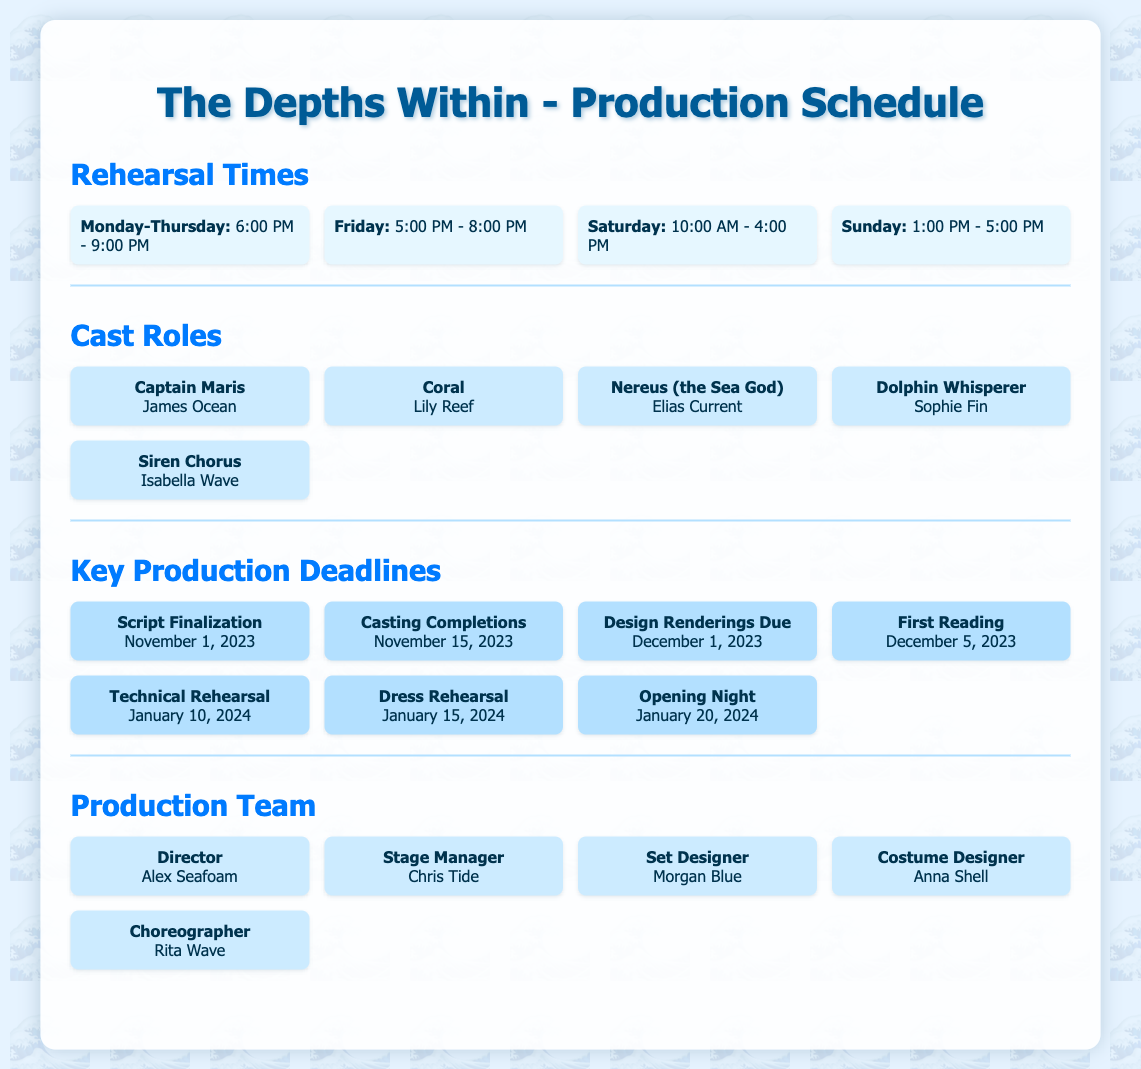What are the rehearsal times on Friday? The rehearsal time on Friday is specified as 5:00 PM - 8:00 PM.
Answer: 5:00 PM - 8:00 PM Who plays the role of Captain Maris? The document states that James Ocean plays the role of Captain Maris.
Answer: James Ocean What is the deadline for script finalization? The document mentions that the script finalization deadline is November 1, 2023.
Answer: November 1, 2023 Who is the choreographer for the production? It is indicated that Rita Wave is the choreographer in the production team section.
Answer: Rita Wave What day is the first reading scheduled? The first reading is scheduled for December 5, 2023, according to the key production deadlines.
Answer: December 5, 2023 How many rehearsals are scheduled on Saturdays? The document states that Saturday rehearsals are from 10:00 AM to 4:00 PM but does not specify the number of rehearsals.
Answer: One Who is the stage manager for the play? The document lists Chris Tide as the stage manager.
Answer: Chris Tide What date is the opening night for the production? According to the key production deadlines, the opening night is on January 20, 2024.
Answer: January 20, 2024 